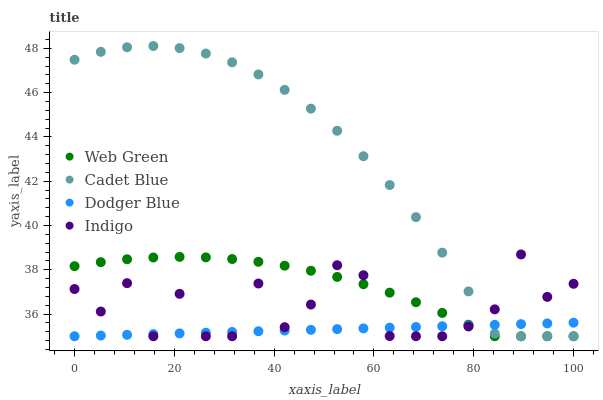Does Dodger Blue have the minimum area under the curve?
Answer yes or no. Yes. Does Cadet Blue have the maximum area under the curve?
Answer yes or no. Yes. Does Cadet Blue have the minimum area under the curve?
Answer yes or no. No. Does Dodger Blue have the maximum area under the curve?
Answer yes or no. No. Is Dodger Blue the smoothest?
Answer yes or no. Yes. Is Indigo the roughest?
Answer yes or no. Yes. Is Cadet Blue the smoothest?
Answer yes or no. No. Is Cadet Blue the roughest?
Answer yes or no. No. Does Indigo have the lowest value?
Answer yes or no. Yes. Does Cadet Blue have the highest value?
Answer yes or no. Yes. Does Dodger Blue have the highest value?
Answer yes or no. No. Does Cadet Blue intersect Indigo?
Answer yes or no. Yes. Is Cadet Blue less than Indigo?
Answer yes or no. No. Is Cadet Blue greater than Indigo?
Answer yes or no. No. 